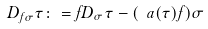<formula> <loc_0><loc_0><loc_500><loc_500>D _ { f \sigma } \tau \colon = f D _ { \sigma } \tau - ( \ a ( \tau ) f ) \sigma</formula> 